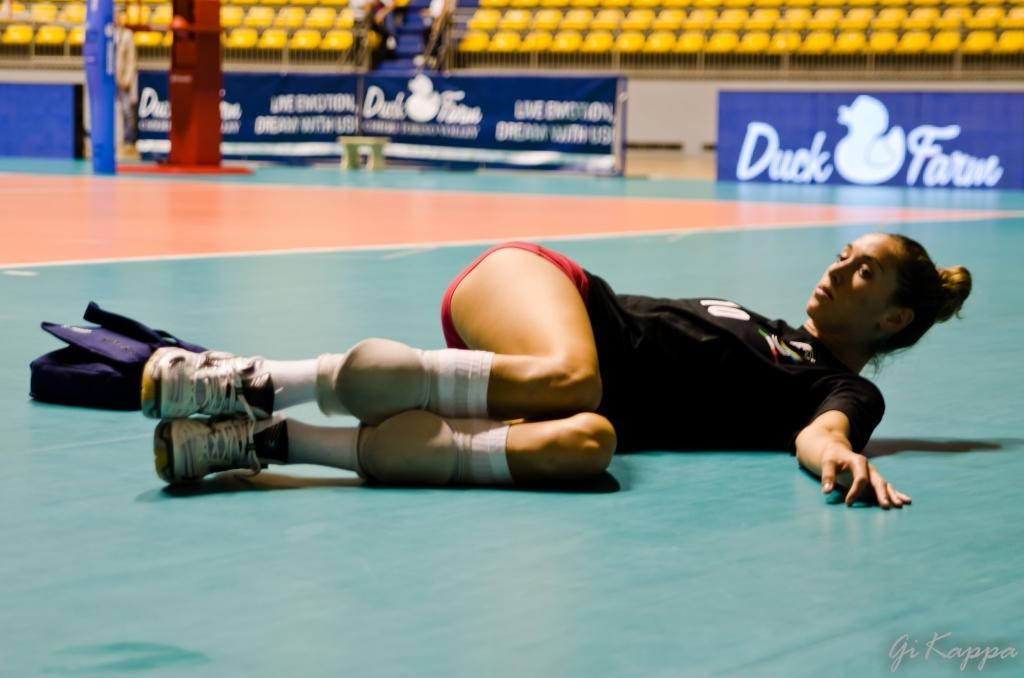What is the woman in the image doing? The woman is laying on the floor in the image. What object can be seen besides the woman? There is a bag in the image. What can be seen in the background of the image? There are chairs and hoardings in the background of the image. What is the weight of the zephyr in the image? There is no zephyr present in the image, as a zephyr refers to a gentle breeze and cannot be weighed. 